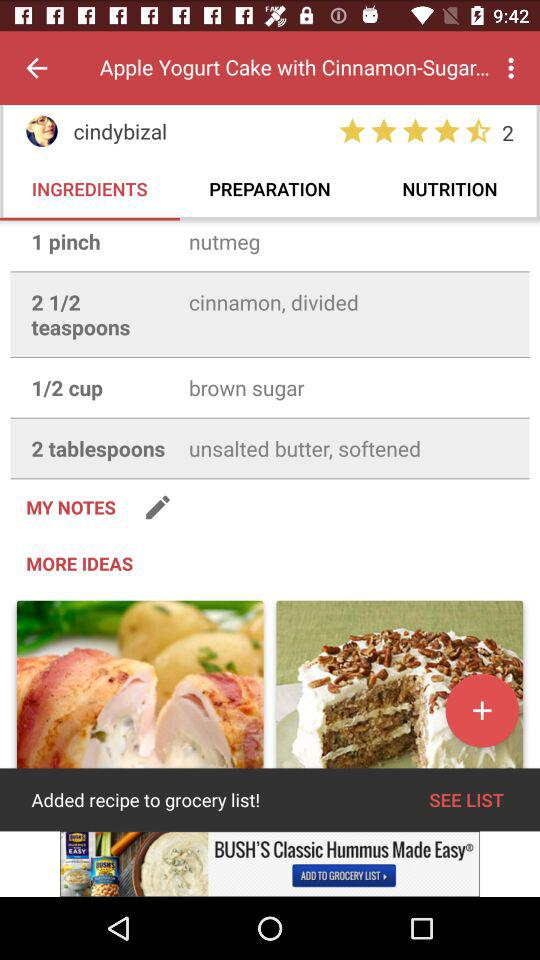What is the quantity of "nutmeg"? The quantity of "nutmeg" is 1 pinch. 